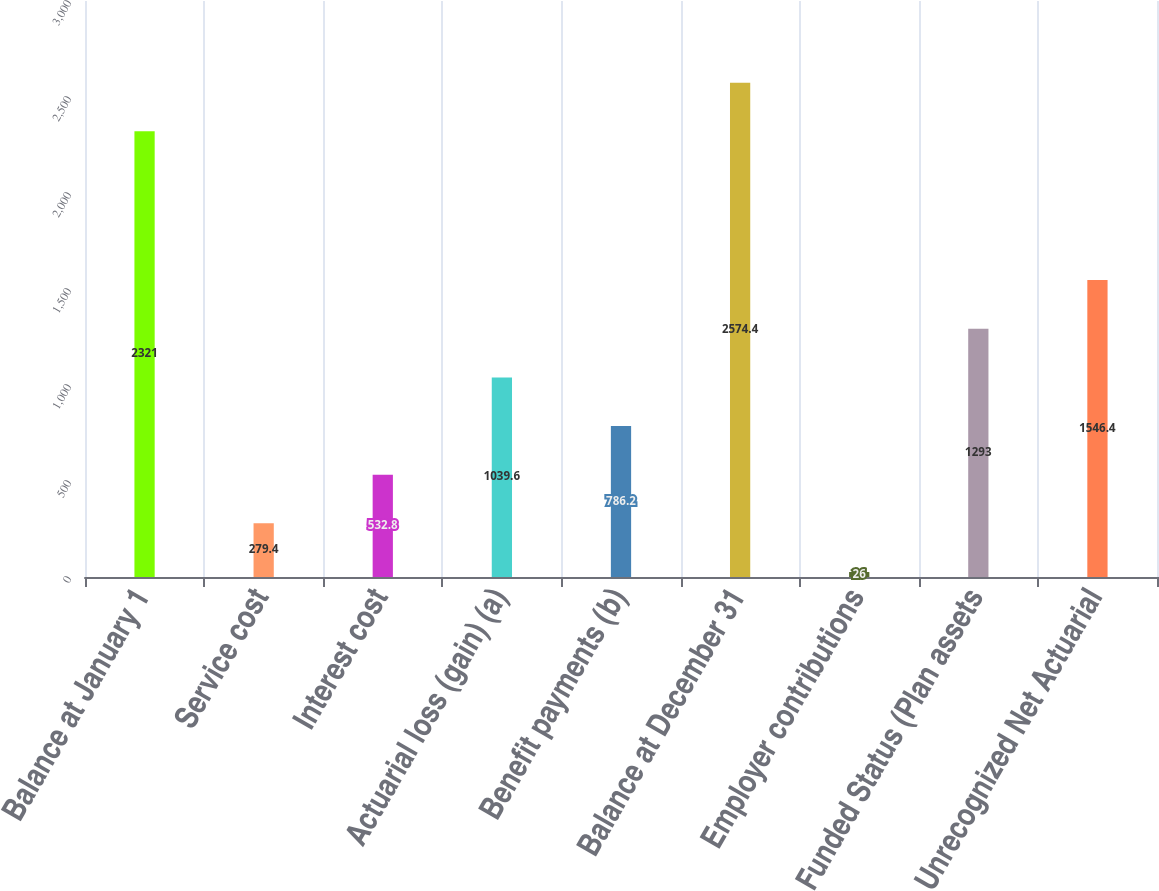Convert chart. <chart><loc_0><loc_0><loc_500><loc_500><bar_chart><fcel>Balance at January 1<fcel>Service cost<fcel>Interest cost<fcel>Actuarial loss (gain) (a)<fcel>Benefit payments (b)<fcel>Balance at December 31<fcel>Employer contributions<fcel>Funded Status (Plan assets<fcel>Unrecognized Net Actuarial<nl><fcel>2321<fcel>279.4<fcel>532.8<fcel>1039.6<fcel>786.2<fcel>2574.4<fcel>26<fcel>1293<fcel>1546.4<nl></chart> 